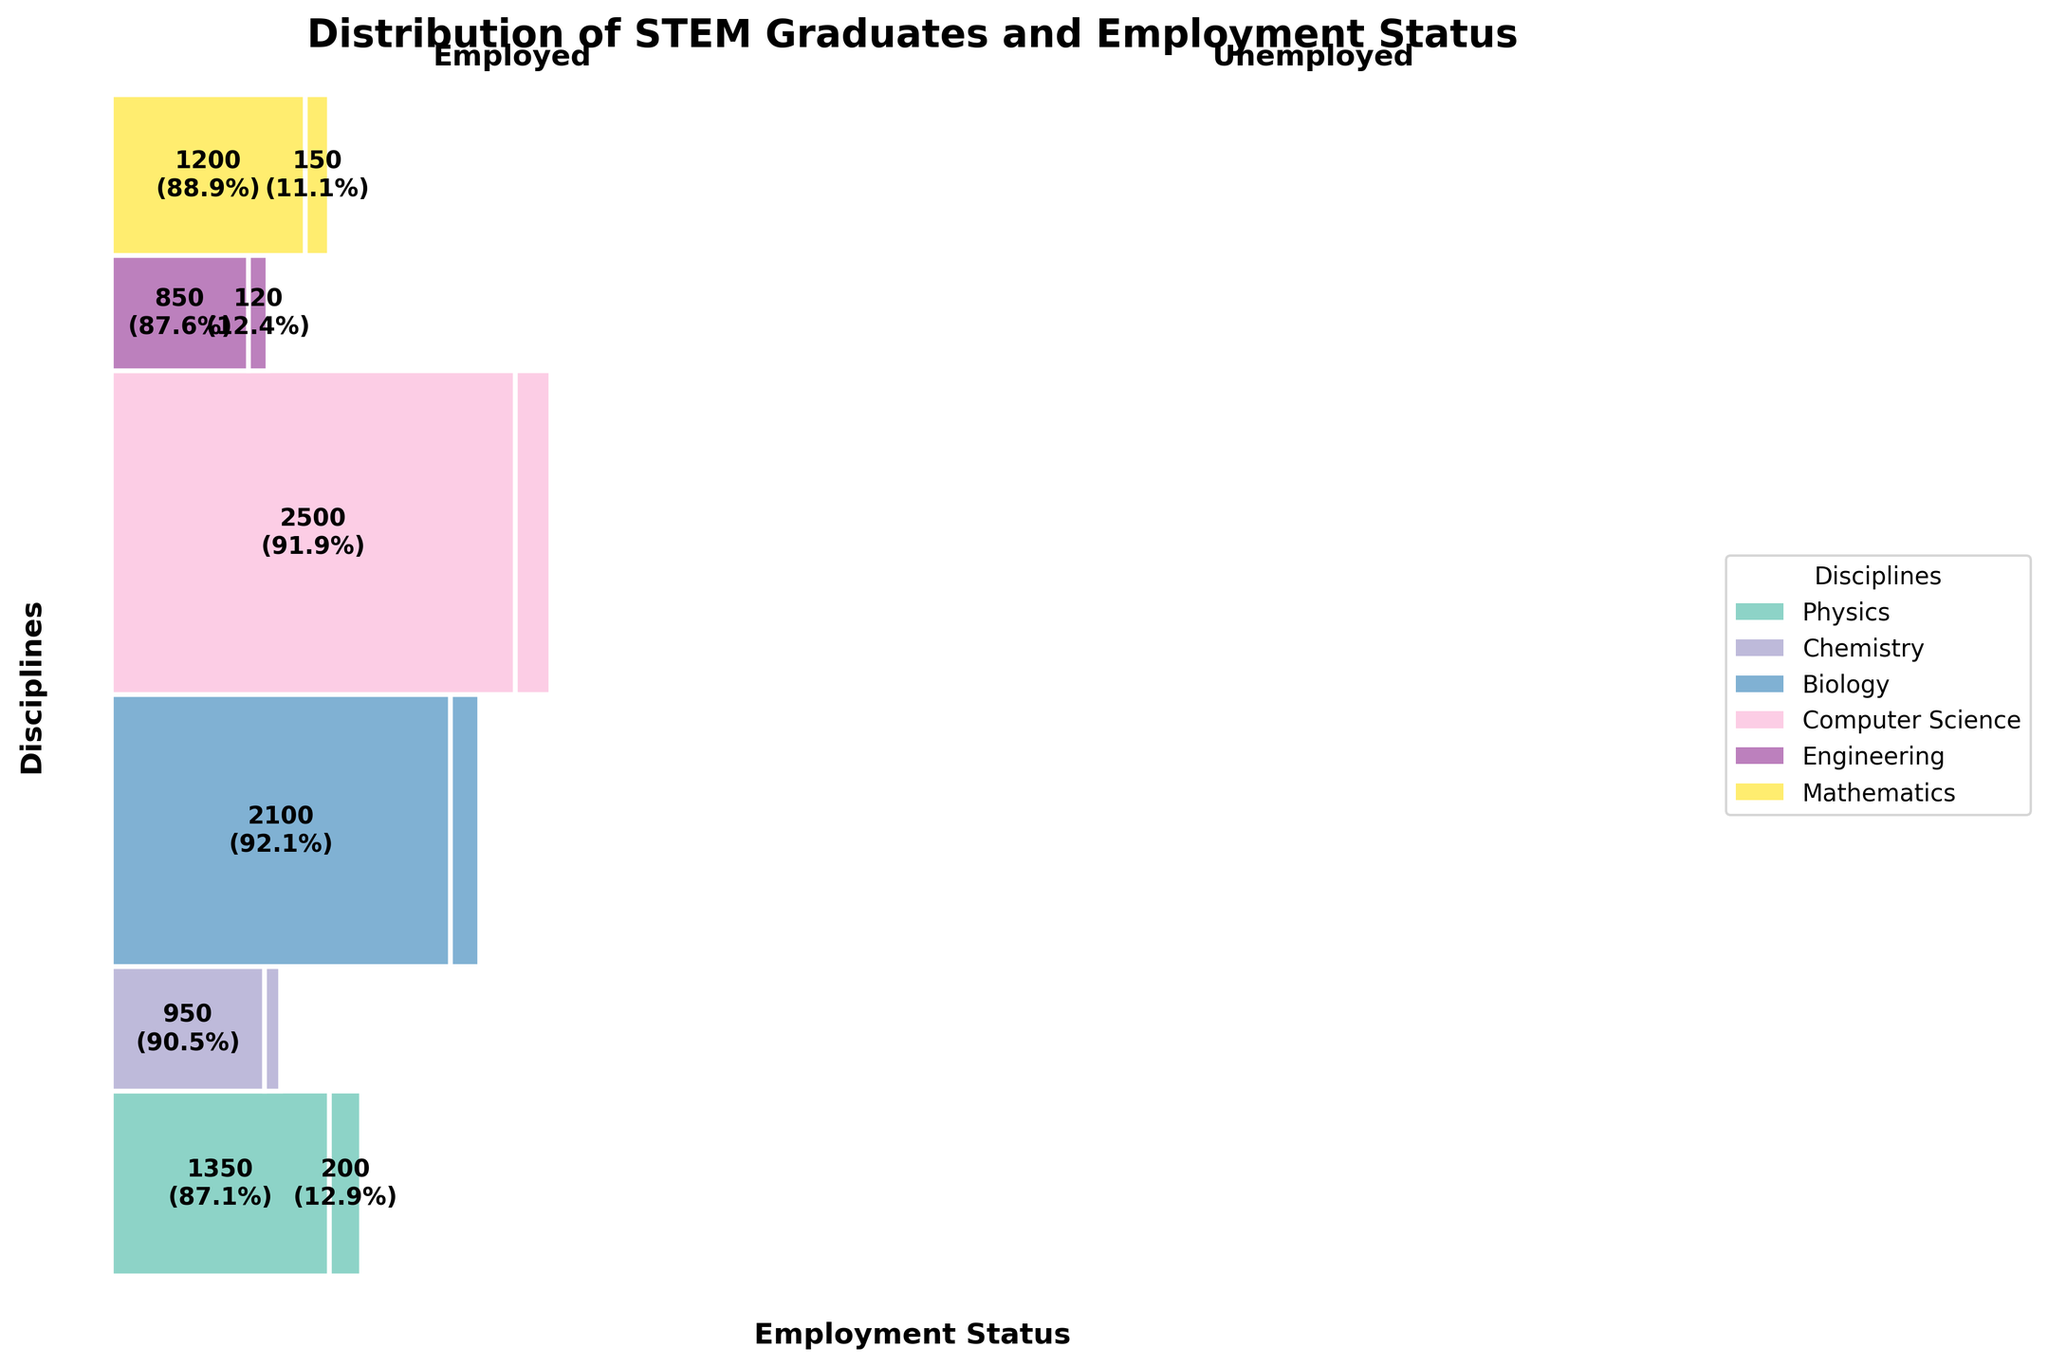What is the title of the figure? The title is provided at the top of the figure and typically summarizes the graphical representation. Here, the title reads "Distribution of STEM Graduates and Employment Status."
Answer: Distribution of STEM Graduates and Employment Status Which discipline has the highest number of graduates employed? The figure allows us to compare the widths of the rectangles representing each discipline. Engineering has the widest rectangle in the "Employed" section, indicating the largest number of employed graduates.
Answer: Engineering What percentage of Physics graduates are unemployed? In the Physics section on the figure, the "Unemployed" rectangle includes text showing the percentage. It indicates that 150 out of the total 1350 graduates are unemployed, which is (150/1350)*100 = 11.1%.
Answer: 11.1% What is the total number of Biology graduates? The figure provides the counts for both employed and unemployed Biology graduates. Summing these up gives 1350 (Employed) + 200 (Unemployed) = 1550.
Answer: 1550 Compare the employment rate between Chemistry and Mathematics graduates. Which has a higher rate? The employment rate can be calculated as (Employed / Total graduates). For Chemistry: 950 / (950 + 100) = 90.5%. For Mathematics: 850 / (850 + 120) = 87.6%. Chemistry has a higher employment rate.
Answer: Chemistry What discipline has the lowest number of unemployed graduates? By examining the smallest "Unemployed" rectangles in the figure, Chemistry has the smallest number of unemployed graduates, which is indicated as 100.
Answer: Chemistry How does the employment rate for Computer Science compare to Biology? Employment rate for Computer Science: 2100 / (2100 + 180) = 92.1%. For Biology: 1350 / (1350 + 200) = 87.1%. Computer Science has a higher employment rate compared to Biology.
Answer: Computer Science What is the total number of unemployed graduates across all disciplines? Sum the unemployed counts from all disciplines: 150 (Physics) + 100 (Chemistry) + 200 (Biology) + 180 (Computer Science) + 220 (Engineering) + 120 (Mathematics) = 970.
Answer: 970 